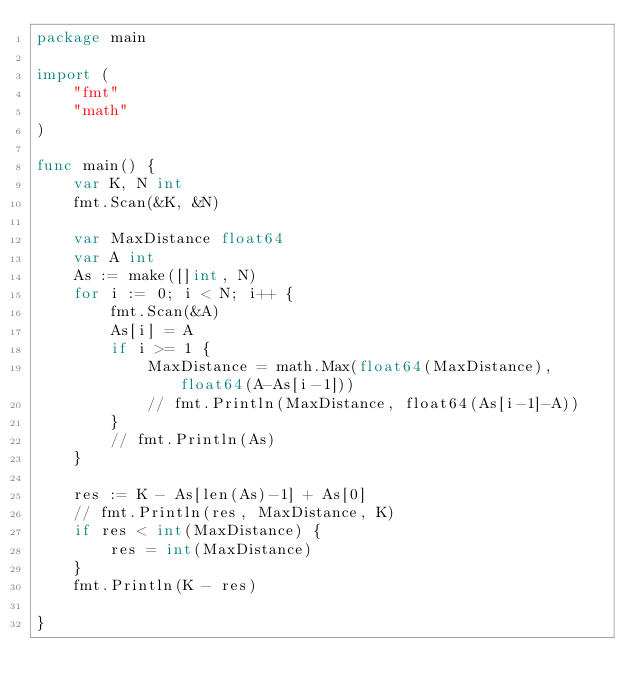<code> <loc_0><loc_0><loc_500><loc_500><_Go_>package main

import (
	"fmt"
	"math"
)

func main() {
	var K, N int
	fmt.Scan(&K, &N)

	var MaxDistance float64
	var A int
	As := make([]int, N)
	for i := 0; i < N; i++ {
		fmt.Scan(&A)
		As[i] = A
		if i >= 1 {
			MaxDistance = math.Max(float64(MaxDistance), float64(A-As[i-1]))
			// fmt.Println(MaxDistance, float64(As[i-1]-A))
		}
		// fmt.Println(As)
	}

	res := K - As[len(As)-1] + As[0]
	// fmt.Println(res, MaxDistance, K)
	if res < int(MaxDistance) {
		res = int(MaxDistance)
	}
	fmt.Println(K - res)

}
</code> 